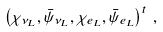<formula> <loc_0><loc_0><loc_500><loc_500>\left ( \chi _ { \nu _ { L } } , \bar { \psi } _ { \nu _ { L } } , \chi _ { e _ { L } } , \bar { \psi } _ { e _ { L } } \right ) ^ { t } \, ,</formula> 